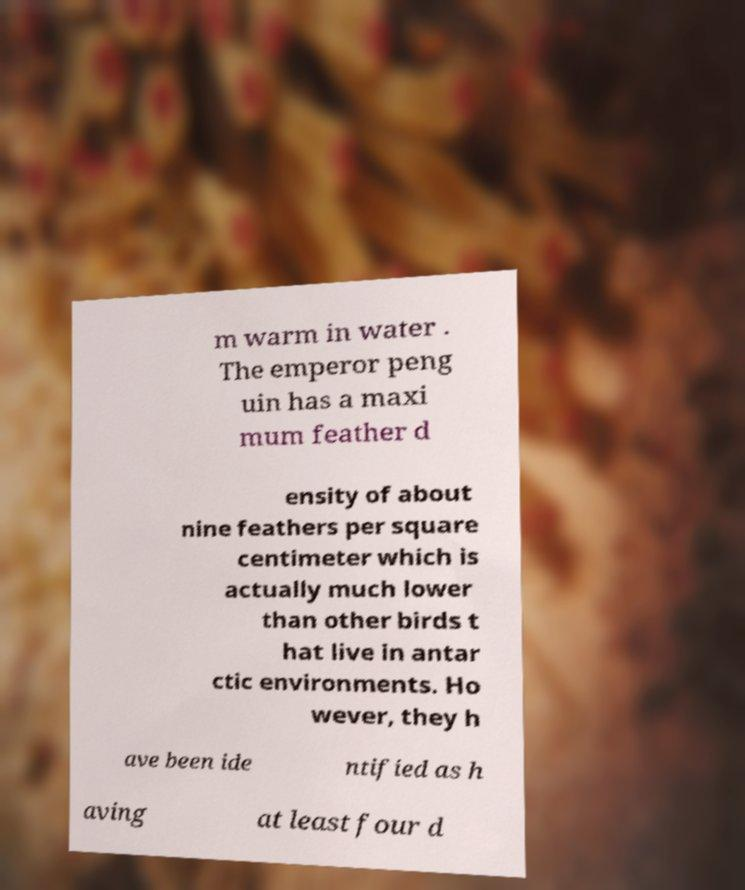Can you accurately transcribe the text from the provided image for me? m warm in water . The emperor peng uin has a maxi mum feather d ensity of about nine feathers per square centimeter which is actually much lower than other birds t hat live in antar ctic environments. Ho wever, they h ave been ide ntified as h aving at least four d 